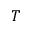Convert formula to latex. <formula><loc_0><loc_0><loc_500><loc_500>T</formula> 